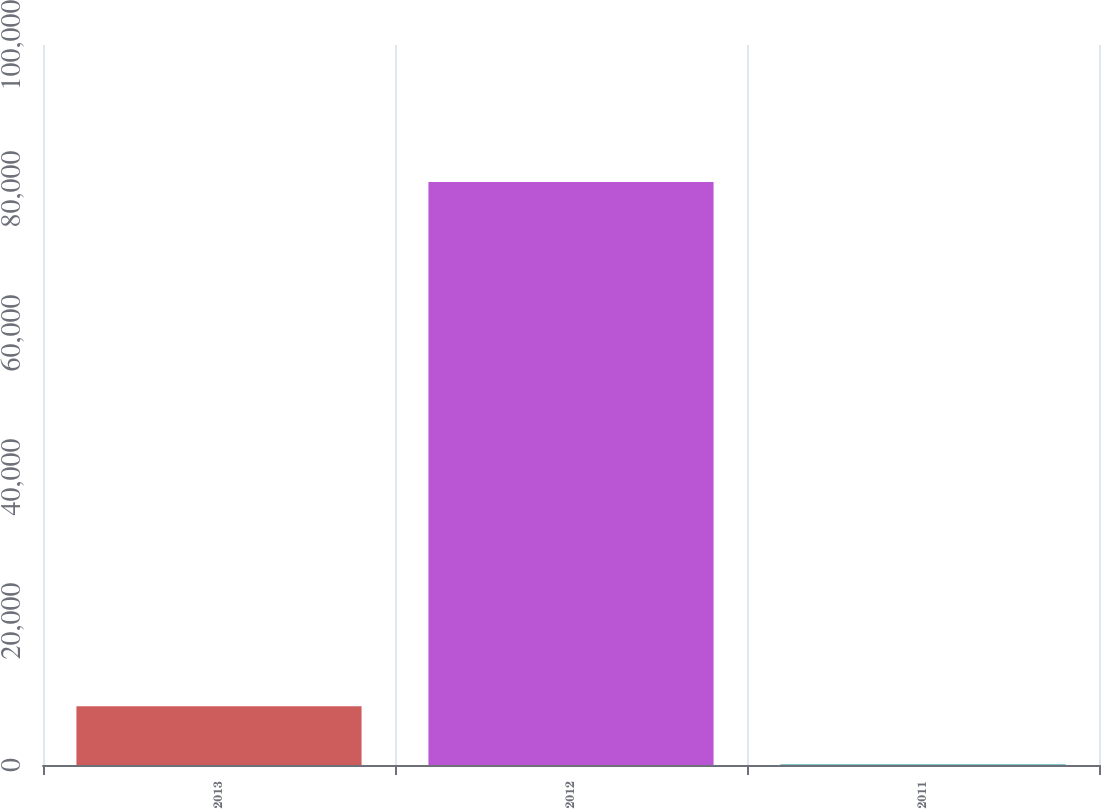<chart> <loc_0><loc_0><loc_500><loc_500><bar_chart><fcel>2013<fcel>2012<fcel>2011<nl><fcel>8154.1<fcel>80974<fcel>63<nl></chart> 